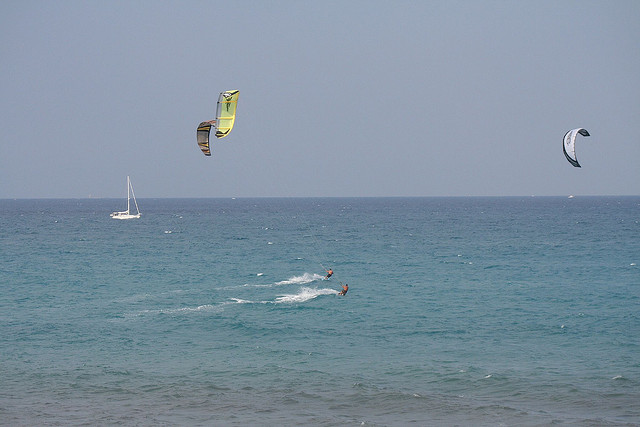Can you create a fictional story about the individuals in the image? In a quiet coastal town, two friends, Alex and Jamie, decided to try kite surfing for the first time. With a bustling curiosity and an adventurous spirit, they took lessons from a seasoned sailor who once circumnavigated the globe. After weeks of practice, Alex and Jamie finally felt the thrill of the wind lifting them above the waves. As they soared and glided, the sense of freedom was incomparable, and they promised to make kite surfing a lifelong passion, exploring new waters and different winds, forever chasing that adrenaline high. 